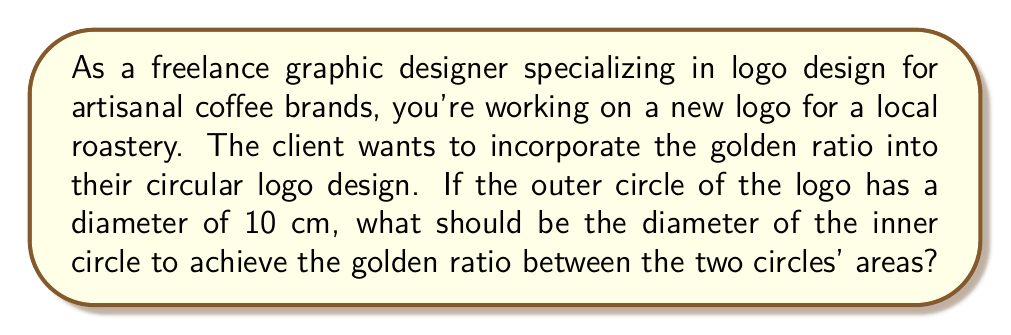Solve this math problem. Let's approach this step-by-step:

1) The golden ratio, denoted by φ (phi), is approximately 1.618034. In our case, we want the ratio of the larger circle's area to the smaller circle's area to be φ.

2) Let's denote the radius of the outer circle as R and the radius of the inner circle as r.

3) We know the diameter of the outer circle is 10 cm, so R = 5 cm.

4) The area of a circle is given by the formula $A = \pi r^2$.

5) We want:

   $$\frac{\text{Area of outer circle}}{\text{Area of inner circle}} = \phi$$

6) Substituting the formula for area:

   $$\frac{\pi R^2}{\pi r^2} = \phi$$

7) The π cancels out:

   $$\frac{R^2}{r^2} = \phi$$

8) Substituting the known values:

   $$\frac{5^2}{r^2} = 1.618034$$

9) Solving for r:

   $$r^2 = \frac{25}{1.618034} = 15.45085$$
   
   $$r = \sqrt{15.45085} = 3.93076 \text{ cm}$$

10) The diameter of the inner circle is twice the radius:

    Diameter = 2r = 2 * 3.93076 = 7.86152 cm

[asy]
size(200);
draw(circle((0,0),5), rgb(0.7,0.5,0.3)+1);
draw(circle((0,0),3.93076), rgb(0.4,0.2,0.1)+1);
label("10 cm", (5,0), E);
label("7.86 cm", (3.93076,0), E);
[/asy]
Answer: The diameter of the inner circle should be approximately 7.86 cm to achieve the golden ratio with the outer circle's area. 